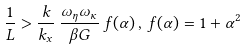Convert formula to latex. <formula><loc_0><loc_0><loc_500><loc_500>\frac { 1 } { L } > \frac { k } { k _ { x } } \, \frac { \omega _ { \eta } \omega _ { \kappa } } { \beta G } \, f ( \alpha ) \, , \, f ( \alpha ) = 1 + \alpha ^ { 2 } \,</formula> 